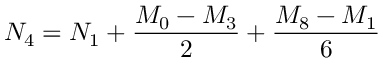Convert formula to latex. <formula><loc_0><loc_0><loc_500><loc_500>N _ { 4 } = N _ { 1 } + { \frac { M _ { 0 } - M _ { 3 } } { 2 } } + { \frac { M _ { 8 } - M _ { 1 } } { 6 } }</formula> 